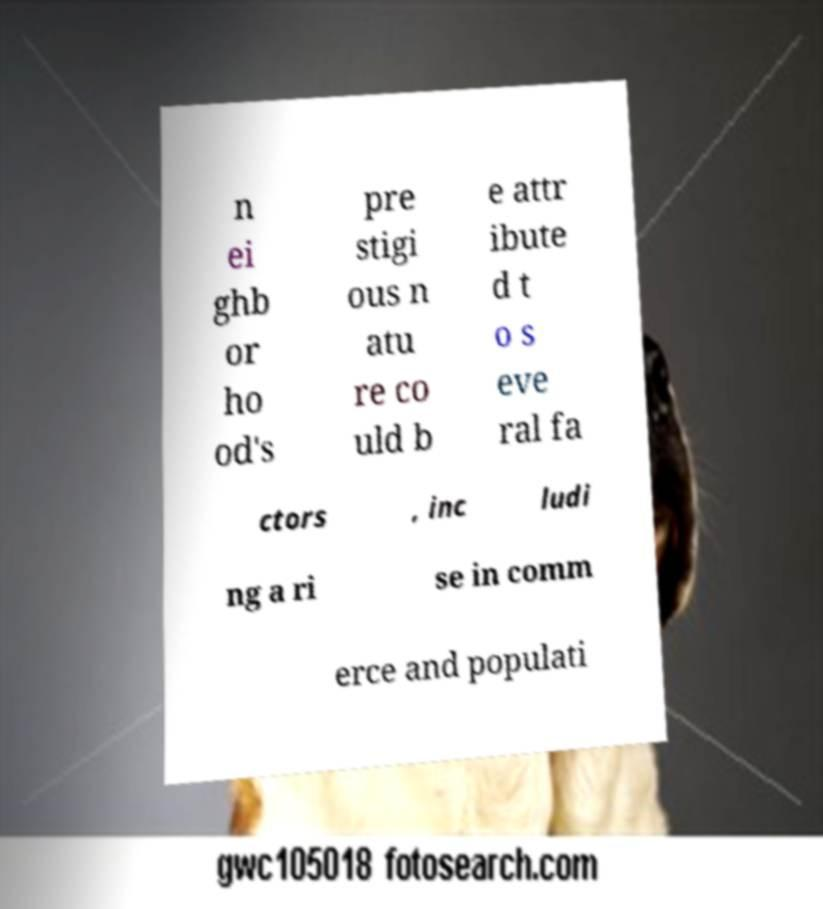Could you assist in decoding the text presented in this image and type it out clearly? n ei ghb or ho od's pre stigi ous n atu re co uld b e attr ibute d t o s eve ral fa ctors , inc ludi ng a ri se in comm erce and populati 